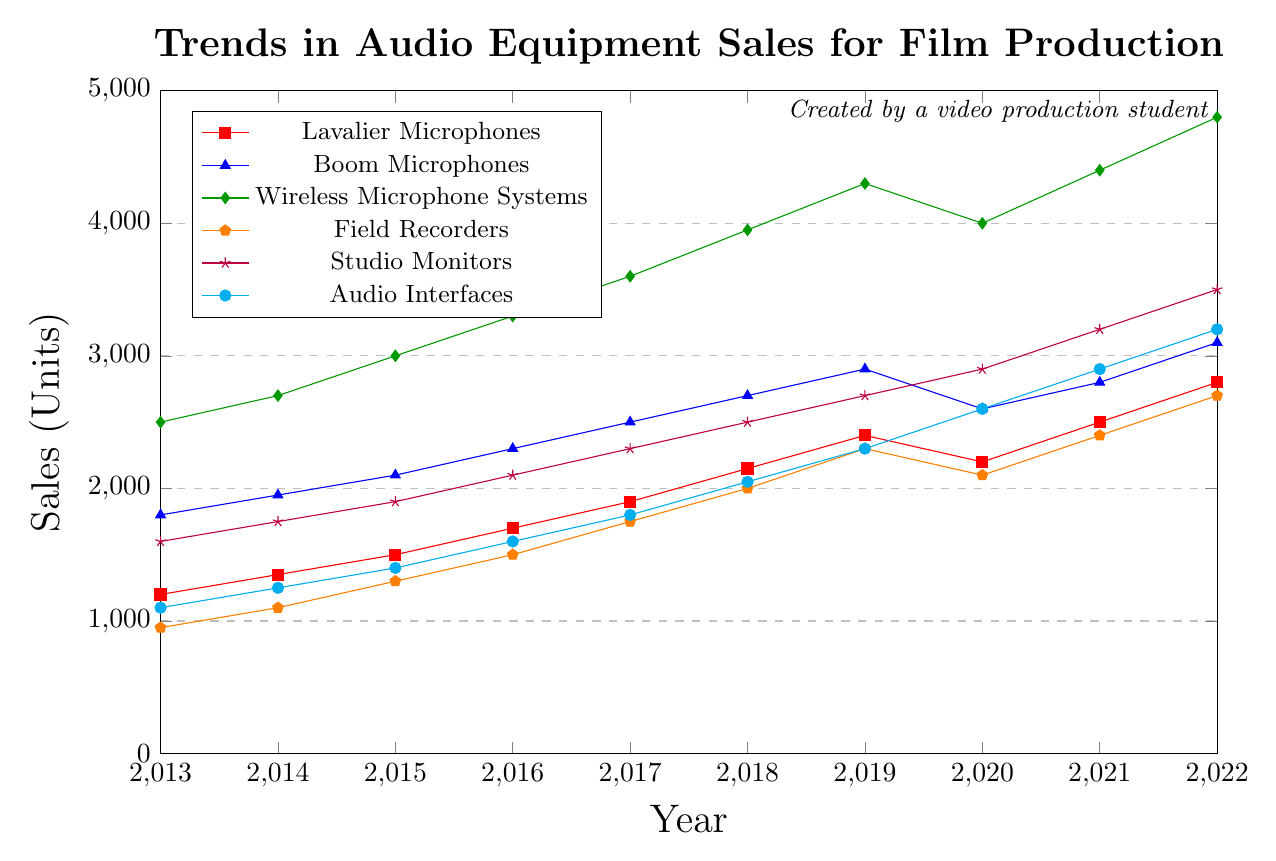Which type of audio equipment had the highest sales in 2019? Look at the data points for all types of audio equipment for the year 2019 and find the highest one. Wireless Microphone Systems had 4300 units sold, which is the highest value.
Answer: Wireless Microphone Systems How did the sales of Lavalier Microphones change from 2020 to 2021? Identify the sales values for Lavalier Microphones for 2020 (2200 units) and 2021 (2500 units). Calculate the difference: 2500 - 2200 = 300 units. The sales increased by 300 units.
Answer: Increased by 300 units What is the difference in sales between Studio Monitors and Audio Interfaces in 2022? Find the sales values for both Studio Monitors (3500 units) and Audio Interfaces (3200 units) in 2022. The difference is 3500 - 3200 = 300 units.
Answer: 300 units Which type of audio equipment showed a consistent increase in sales every year? Look for the types of audio equipment where each year's sales numbers are higher than the previous year's. Wireless Microphone Systems and Studio Monitors show consistent yearly increases.
Answer: Wireless Microphone Systems and Studio Monitors What is the average sales of Field Recorders over the decade? Sum the sales values for Field Recorders from 2013 to 2022: 950 + 1100 + 1300 + 1500 + 1750 + 2000 + 2300 + 2100 + 2400 + 2700 = 18100 units. Divide by the number of years (10): 18100 / 10 = 1810 units.
Answer: 1810 units Which type of microphone had higher sales in 2016, Lavalier Microphones or Boom Microphones? Compare the sales values for Lavalier Microphones (1700 units) and Boom Microphones (2300 units) in 2016. Boom Microphones had higher sales.
Answer: Boom Microphones By how much did sales of Audio Interfaces increase from 2015 to 2022? Identify the sales values for Audio Interfaces in 2015 (1400 units) and 2022 (3200 units). Calculate the difference: 3200 - 1400 = 1800 units.
Answer: 1800 units Which equipment had the sharpest decline in sales from 2019 to 2020? Compare the sales numbers for all equipment types between 2019 and 2020 to find which had the greatest decrease. Wireless Microphone Systems decreased from 4300 units in 2019 to 4000 units in 2020, a drop of 300 units, which is the sharpest decline.
Answer: Wireless Microphone Systems What is the total sales of Boom Microphones from 2017 to 2020? Sum the sales values for Boom Microphones from 2017 to 2020: 2500 + 2700 + 2900 + 2600 = 10700 units.
Answer: 10700 units 